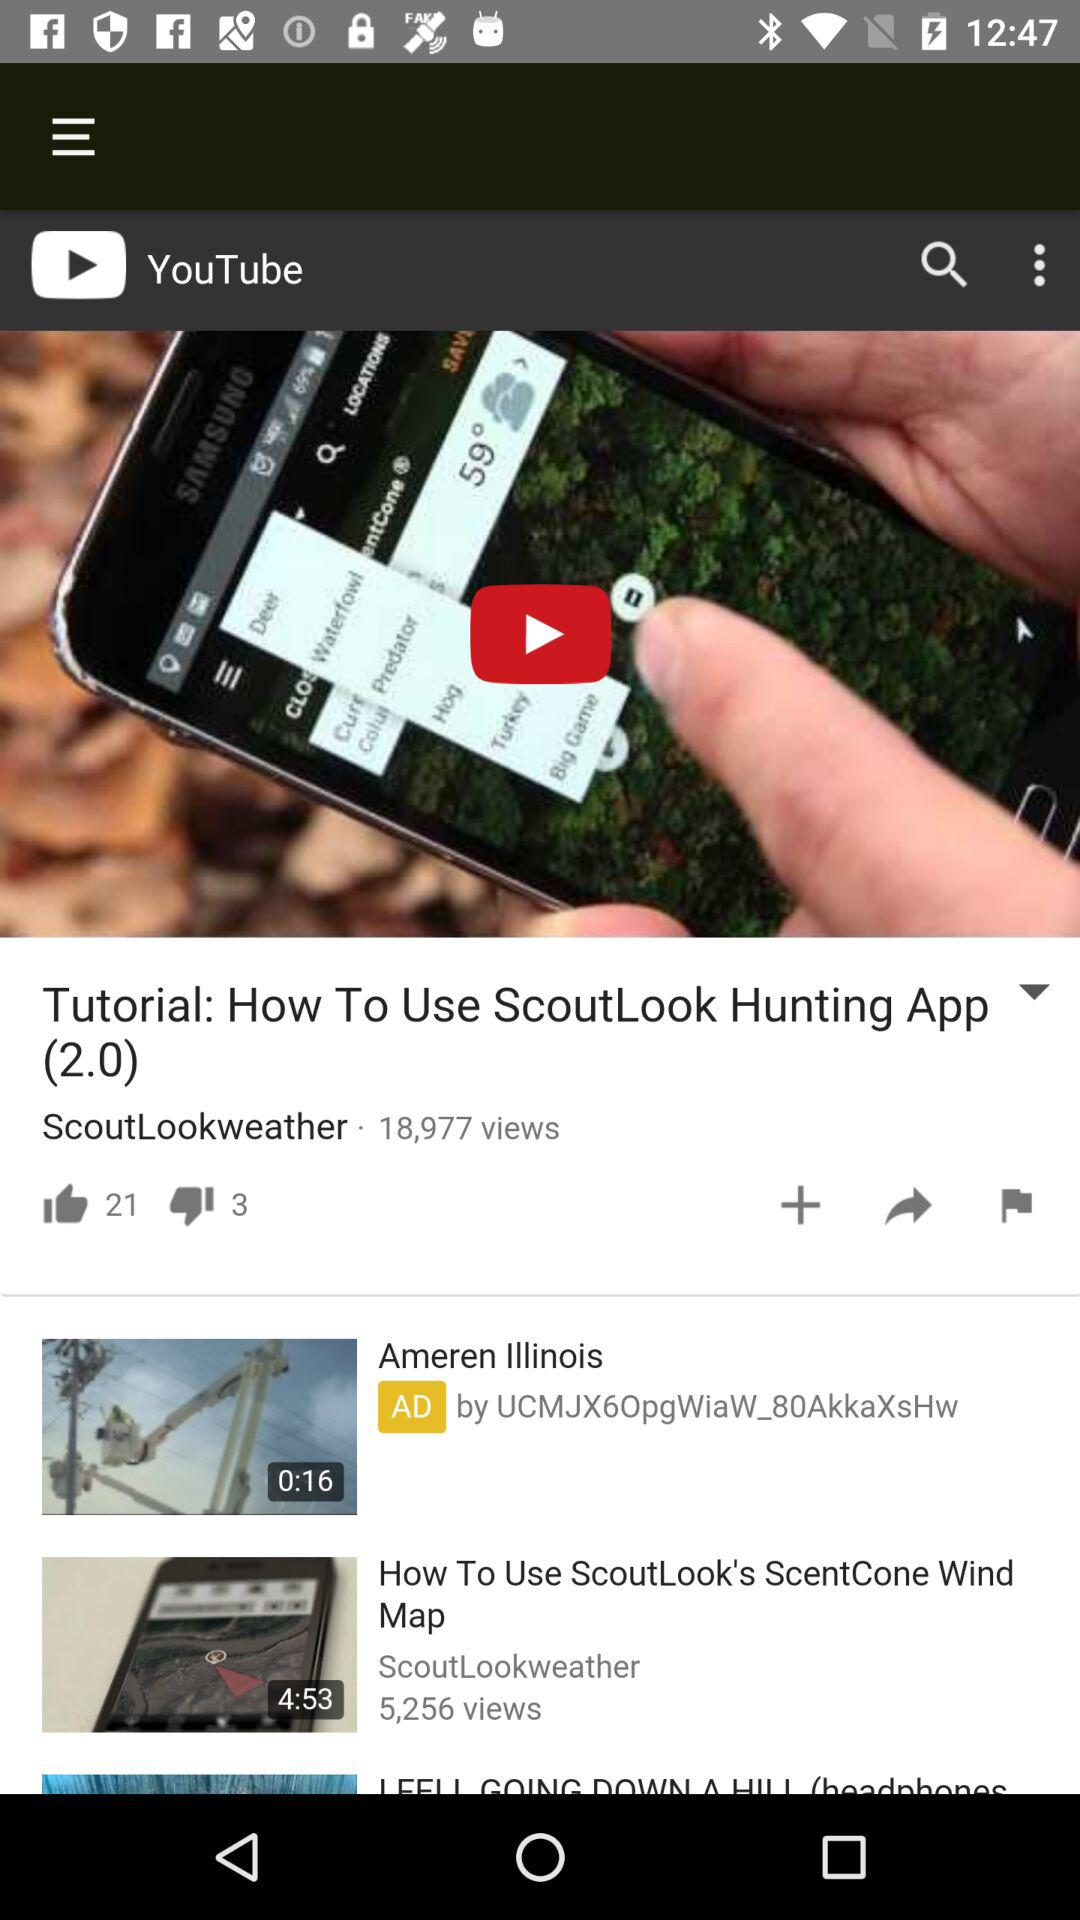How many thumbs up are there on the first video?
Answer the question using a single word or phrase. 21 